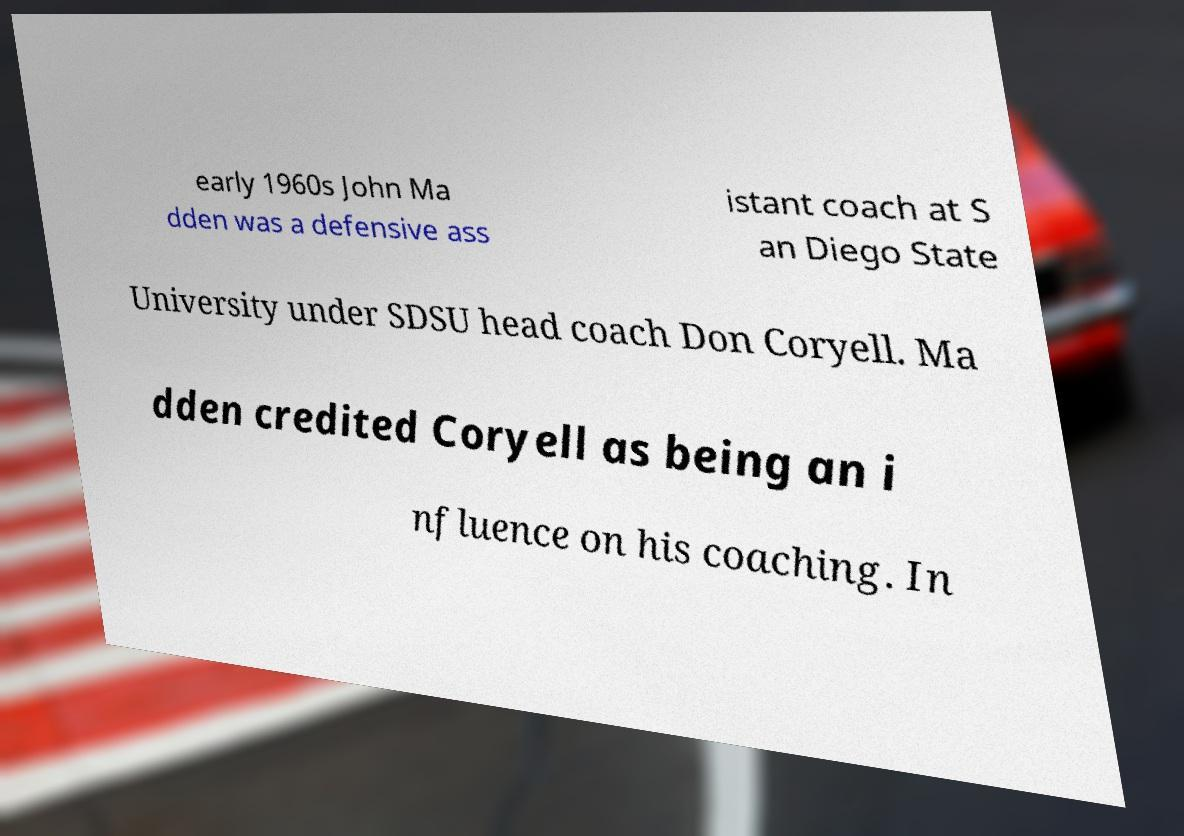What messages or text are displayed in this image? I need them in a readable, typed format. early 1960s John Ma dden was a defensive ass istant coach at S an Diego State University under SDSU head coach Don Coryell. Ma dden credited Coryell as being an i nfluence on his coaching. In 